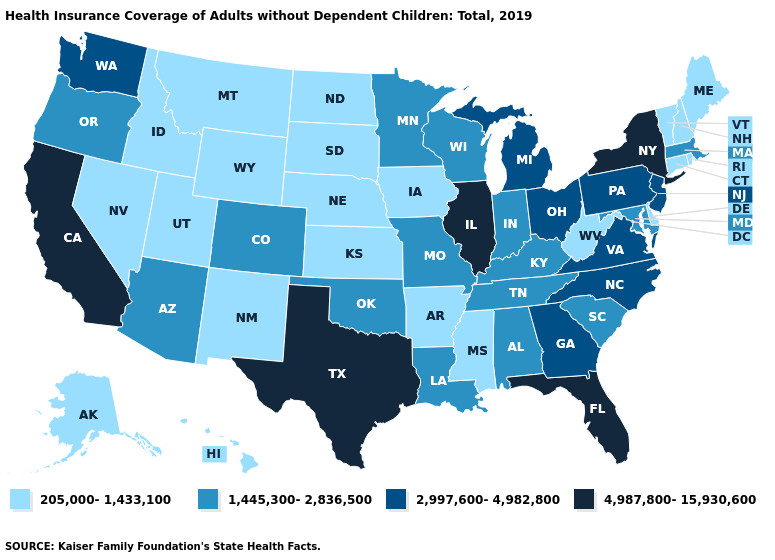Which states have the highest value in the USA?
Be succinct. California, Florida, Illinois, New York, Texas. What is the value of Wyoming?
Keep it brief. 205,000-1,433,100. Name the states that have a value in the range 4,987,800-15,930,600?
Write a very short answer. California, Florida, Illinois, New York, Texas. Does California have the highest value in the West?
Be succinct. Yes. Does the first symbol in the legend represent the smallest category?
Short answer required. Yes. What is the value of Pennsylvania?
Quick response, please. 2,997,600-4,982,800. What is the lowest value in states that border Utah?
Concise answer only. 205,000-1,433,100. What is the value of South Carolina?
Quick response, please. 1,445,300-2,836,500. Among the states that border Iowa , which have the highest value?
Concise answer only. Illinois. What is the highest value in states that border North Carolina?
Short answer required. 2,997,600-4,982,800. How many symbols are there in the legend?
Answer briefly. 4. What is the highest value in the USA?
Keep it brief. 4,987,800-15,930,600. What is the value of Maryland?
Write a very short answer. 1,445,300-2,836,500. Name the states that have a value in the range 2,997,600-4,982,800?
Be succinct. Georgia, Michigan, New Jersey, North Carolina, Ohio, Pennsylvania, Virginia, Washington. What is the lowest value in the MidWest?
Keep it brief. 205,000-1,433,100. 